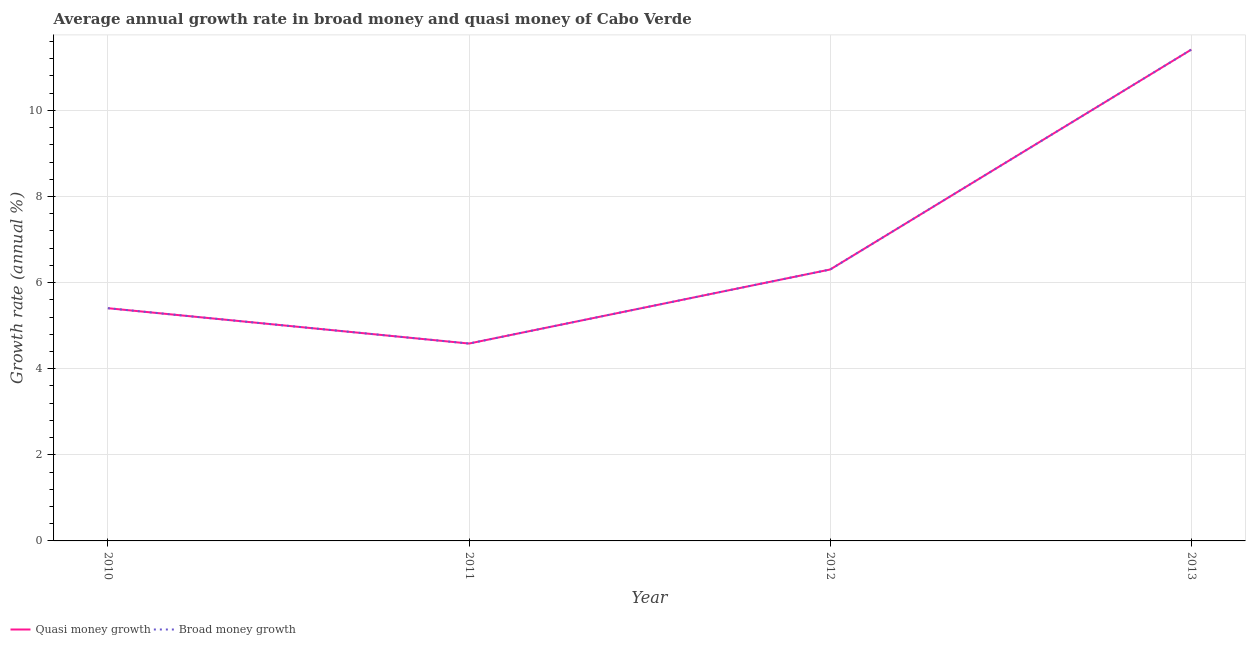How many different coloured lines are there?
Keep it short and to the point. 2. Does the line corresponding to annual growth rate in quasi money intersect with the line corresponding to annual growth rate in broad money?
Offer a very short reply. Yes. Is the number of lines equal to the number of legend labels?
Provide a short and direct response. Yes. What is the annual growth rate in broad money in 2010?
Offer a terse response. 5.41. Across all years, what is the maximum annual growth rate in quasi money?
Provide a succinct answer. 11.41. Across all years, what is the minimum annual growth rate in broad money?
Keep it short and to the point. 4.58. In which year was the annual growth rate in quasi money maximum?
Offer a terse response. 2013. In which year was the annual growth rate in quasi money minimum?
Offer a very short reply. 2011. What is the total annual growth rate in quasi money in the graph?
Keep it short and to the point. 27.71. What is the difference between the annual growth rate in quasi money in 2011 and that in 2013?
Offer a terse response. -6.83. What is the difference between the annual growth rate in quasi money in 2013 and the annual growth rate in broad money in 2012?
Your answer should be compact. 5.11. What is the average annual growth rate in quasi money per year?
Make the answer very short. 6.93. In the year 2011, what is the difference between the annual growth rate in broad money and annual growth rate in quasi money?
Your answer should be very brief. 0. In how many years, is the annual growth rate in broad money greater than 3.2 %?
Provide a succinct answer. 4. What is the ratio of the annual growth rate in quasi money in 2010 to that in 2011?
Keep it short and to the point. 1.18. What is the difference between the highest and the second highest annual growth rate in quasi money?
Ensure brevity in your answer.  5.11. What is the difference between the highest and the lowest annual growth rate in quasi money?
Provide a short and direct response. 6.83. In how many years, is the annual growth rate in broad money greater than the average annual growth rate in broad money taken over all years?
Provide a succinct answer. 1. How many lines are there?
Your answer should be very brief. 2. How many years are there in the graph?
Provide a succinct answer. 4. What is the difference between two consecutive major ticks on the Y-axis?
Offer a very short reply. 2. Are the values on the major ticks of Y-axis written in scientific E-notation?
Keep it short and to the point. No. Where does the legend appear in the graph?
Offer a terse response. Bottom left. How are the legend labels stacked?
Your answer should be very brief. Horizontal. What is the title of the graph?
Offer a very short reply. Average annual growth rate in broad money and quasi money of Cabo Verde. Does "Unregistered firms" appear as one of the legend labels in the graph?
Ensure brevity in your answer.  No. What is the label or title of the Y-axis?
Offer a very short reply. Growth rate (annual %). What is the Growth rate (annual %) in Quasi money growth in 2010?
Your response must be concise. 5.41. What is the Growth rate (annual %) of Broad money growth in 2010?
Give a very brief answer. 5.41. What is the Growth rate (annual %) in Quasi money growth in 2011?
Ensure brevity in your answer.  4.58. What is the Growth rate (annual %) of Broad money growth in 2011?
Give a very brief answer. 4.58. What is the Growth rate (annual %) of Quasi money growth in 2012?
Your answer should be compact. 6.3. What is the Growth rate (annual %) of Broad money growth in 2012?
Keep it short and to the point. 6.3. What is the Growth rate (annual %) in Quasi money growth in 2013?
Your response must be concise. 11.41. What is the Growth rate (annual %) in Broad money growth in 2013?
Your answer should be compact. 11.41. Across all years, what is the maximum Growth rate (annual %) in Quasi money growth?
Offer a terse response. 11.41. Across all years, what is the maximum Growth rate (annual %) of Broad money growth?
Make the answer very short. 11.41. Across all years, what is the minimum Growth rate (annual %) in Quasi money growth?
Provide a succinct answer. 4.58. Across all years, what is the minimum Growth rate (annual %) in Broad money growth?
Keep it short and to the point. 4.58. What is the total Growth rate (annual %) of Quasi money growth in the graph?
Your answer should be compact. 27.71. What is the total Growth rate (annual %) of Broad money growth in the graph?
Offer a terse response. 27.71. What is the difference between the Growth rate (annual %) in Quasi money growth in 2010 and that in 2011?
Your answer should be compact. 0.82. What is the difference between the Growth rate (annual %) in Broad money growth in 2010 and that in 2011?
Offer a very short reply. 0.82. What is the difference between the Growth rate (annual %) of Quasi money growth in 2010 and that in 2012?
Provide a short and direct response. -0.9. What is the difference between the Growth rate (annual %) of Broad money growth in 2010 and that in 2012?
Give a very brief answer. -0.9. What is the difference between the Growth rate (annual %) in Quasi money growth in 2010 and that in 2013?
Offer a very short reply. -6.01. What is the difference between the Growth rate (annual %) of Broad money growth in 2010 and that in 2013?
Give a very brief answer. -6.01. What is the difference between the Growth rate (annual %) in Quasi money growth in 2011 and that in 2012?
Provide a succinct answer. -1.72. What is the difference between the Growth rate (annual %) of Broad money growth in 2011 and that in 2012?
Your answer should be compact. -1.72. What is the difference between the Growth rate (annual %) of Quasi money growth in 2011 and that in 2013?
Offer a terse response. -6.83. What is the difference between the Growth rate (annual %) in Broad money growth in 2011 and that in 2013?
Offer a terse response. -6.83. What is the difference between the Growth rate (annual %) in Quasi money growth in 2012 and that in 2013?
Give a very brief answer. -5.11. What is the difference between the Growth rate (annual %) in Broad money growth in 2012 and that in 2013?
Offer a very short reply. -5.11. What is the difference between the Growth rate (annual %) in Quasi money growth in 2010 and the Growth rate (annual %) in Broad money growth in 2011?
Provide a short and direct response. 0.82. What is the difference between the Growth rate (annual %) in Quasi money growth in 2010 and the Growth rate (annual %) in Broad money growth in 2012?
Give a very brief answer. -0.9. What is the difference between the Growth rate (annual %) in Quasi money growth in 2010 and the Growth rate (annual %) in Broad money growth in 2013?
Your answer should be very brief. -6.01. What is the difference between the Growth rate (annual %) of Quasi money growth in 2011 and the Growth rate (annual %) of Broad money growth in 2012?
Offer a very short reply. -1.72. What is the difference between the Growth rate (annual %) of Quasi money growth in 2011 and the Growth rate (annual %) of Broad money growth in 2013?
Offer a terse response. -6.83. What is the difference between the Growth rate (annual %) in Quasi money growth in 2012 and the Growth rate (annual %) in Broad money growth in 2013?
Give a very brief answer. -5.11. What is the average Growth rate (annual %) in Quasi money growth per year?
Offer a very short reply. 6.93. What is the average Growth rate (annual %) of Broad money growth per year?
Provide a succinct answer. 6.93. In the year 2010, what is the difference between the Growth rate (annual %) in Quasi money growth and Growth rate (annual %) in Broad money growth?
Give a very brief answer. 0. In the year 2013, what is the difference between the Growth rate (annual %) of Quasi money growth and Growth rate (annual %) of Broad money growth?
Provide a succinct answer. 0. What is the ratio of the Growth rate (annual %) of Quasi money growth in 2010 to that in 2011?
Your answer should be very brief. 1.18. What is the ratio of the Growth rate (annual %) in Broad money growth in 2010 to that in 2011?
Keep it short and to the point. 1.18. What is the ratio of the Growth rate (annual %) of Quasi money growth in 2010 to that in 2012?
Provide a short and direct response. 0.86. What is the ratio of the Growth rate (annual %) in Broad money growth in 2010 to that in 2012?
Provide a short and direct response. 0.86. What is the ratio of the Growth rate (annual %) in Quasi money growth in 2010 to that in 2013?
Provide a succinct answer. 0.47. What is the ratio of the Growth rate (annual %) of Broad money growth in 2010 to that in 2013?
Your answer should be very brief. 0.47. What is the ratio of the Growth rate (annual %) in Quasi money growth in 2011 to that in 2012?
Give a very brief answer. 0.73. What is the ratio of the Growth rate (annual %) of Broad money growth in 2011 to that in 2012?
Make the answer very short. 0.73. What is the ratio of the Growth rate (annual %) in Quasi money growth in 2011 to that in 2013?
Your response must be concise. 0.4. What is the ratio of the Growth rate (annual %) of Broad money growth in 2011 to that in 2013?
Your answer should be compact. 0.4. What is the ratio of the Growth rate (annual %) in Quasi money growth in 2012 to that in 2013?
Your response must be concise. 0.55. What is the ratio of the Growth rate (annual %) in Broad money growth in 2012 to that in 2013?
Your answer should be compact. 0.55. What is the difference between the highest and the second highest Growth rate (annual %) of Quasi money growth?
Provide a succinct answer. 5.11. What is the difference between the highest and the second highest Growth rate (annual %) in Broad money growth?
Give a very brief answer. 5.11. What is the difference between the highest and the lowest Growth rate (annual %) in Quasi money growth?
Your answer should be very brief. 6.83. What is the difference between the highest and the lowest Growth rate (annual %) in Broad money growth?
Offer a very short reply. 6.83. 